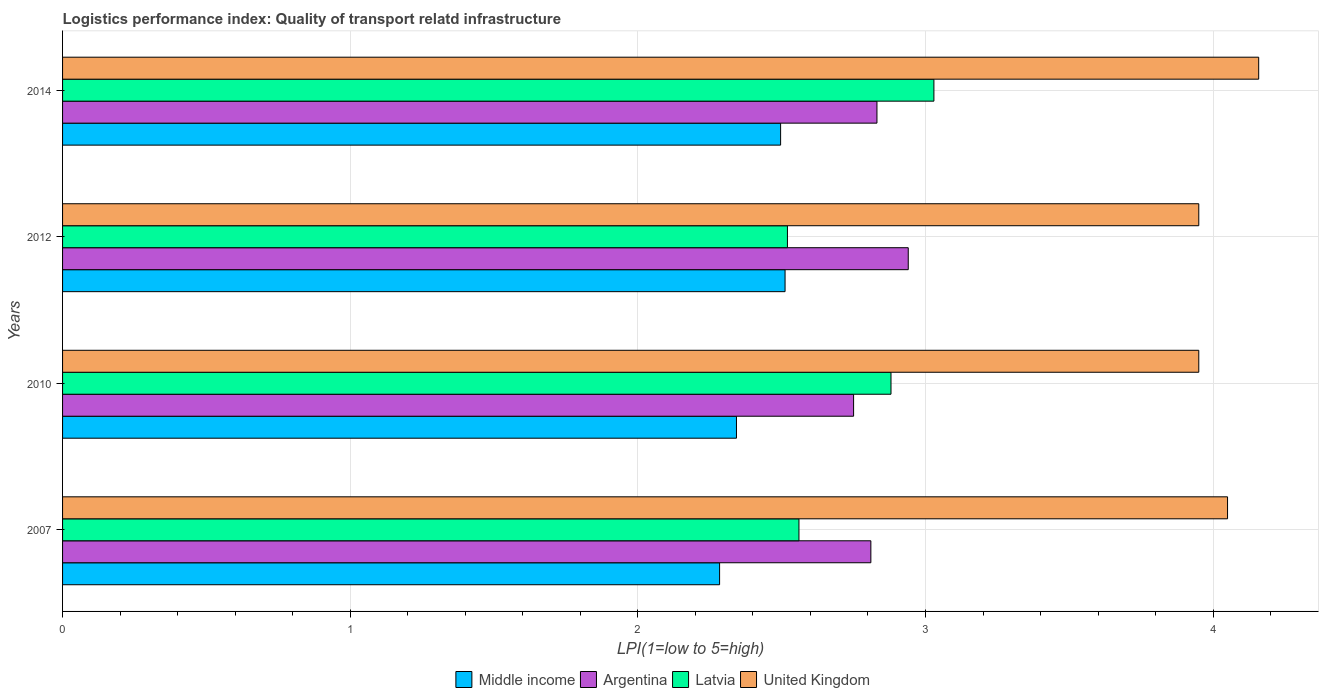How many different coloured bars are there?
Ensure brevity in your answer.  4. How many groups of bars are there?
Provide a short and direct response. 4. Are the number of bars on each tick of the Y-axis equal?
Your answer should be compact. Yes. How many bars are there on the 2nd tick from the top?
Give a very brief answer. 4. How many bars are there on the 3rd tick from the bottom?
Offer a terse response. 4. What is the label of the 1st group of bars from the top?
Your answer should be compact. 2014. In how many cases, is the number of bars for a given year not equal to the number of legend labels?
Offer a terse response. 0. What is the logistics performance index in Latvia in 2012?
Your answer should be very brief. 2.52. Across all years, what is the maximum logistics performance index in United Kingdom?
Give a very brief answer. 4.16. Across all years, what is the minimum logistics performance index in Argentina?
Offer a terse response. 2.75. In which year was the logistics performance index in Middle income minimum?
Ensure brevity in your answer.  2007. What is the total logistics performance index in United Kingdom in the graph?
Offer a terse response. 16.11. What is the difference between the logistics performance index in Argentina in 2010 and that in 2014?
Your response must be concise. -0.08. What is the difference between the logistics performance index in United Kingdom in 2007 and the logistics performance index in Latvia in 2012?
Offer a very short reply. 1.53. What is the average logistics performance index in Middle income per year?
Keep it short and to the point. 2.41. In the year 2014, what is the difference between the logistics performance index in Middle income and logistics performance index in United Kingdom?
Keep it short and to the point. -1.66. In how many years, is the logistics performance index in Middle income greater than 3.6 ?
Offer a very short reply. 0. What is the ratio of the logistics performance index in United Kingdom in 2007 to that in 2010?
Your response must be concise. 1.03. Is the logistics performance index in Latvia in 2007 less than that in 2014?
Your response must be concise. Yes. What is the difference between the highest and the second highest logistics performance index in Latvia?
Give a very brief answer. 0.15. What is the difference between the highest and the lowest logistics performance index in Latvia?
Your answer should be compact. 0.51. In how many years, is the logistics performance index in Latvia greater than the average logistics performance index in Latvia taken over all years?
Your answer should be compact. 2. Is the sum of the logistics performance index in Argentina in 2012 and 2014 greater than the maximum logistics performance index in United Kingdom across all years?
Ensure brevity in your answer.  Yes. Is it the case that in every year, the sum of the logistics performance index in Argentina and logistics performance index in Middle income is greater than the sum of logistics performance index in Latvia and logistics performance index in United Kingdom?
Give a very brief answer. No. What does the 2nd bar from the top in 2014 represents?
Offer a very short reply. Latvia. What does the 2nd bar from the bottom in 2010 represents?
Make the answer very short. Argentina. How many years are there in the graph?
Offer a very short reply. 4. Does the graph contain any zero values?
Your response must be concise. No. Does the graph contain grids?
Ensure brevity in your answer.  Yes. Where does the legend appear in the graph?
Give a very brief answer. Bottom center. How are the legend labels stacked?
Ensure brevity in your answer.  Horizontal. What is the title of the graph?
Provide a short and direct response. Logistics performance index: Quality of transport relatd infrastructure. Does "Norway" appear as one of the legend labels in the graph?
Give a very brief answer. No. What is the label or title of the X-axis?
Ensure brevity in your answer.  LPI(1=low to 5=high). What is the label or title of the Y-axis?
Your response must be concise. Years. What is the LPI(1=low to 5=high) in Middle income in 2007?
Offer a terse response. 2.28. What is the LPI(1=low to 5=high) in Argentina in 2007?
Provide a short and direct response. 2.81. What is the LPI(1=low to 5=high) in Latvia in 2007?
Provide a short and direct response. 2.56. What is the LPI(1=low to 5=high) in United Kingdom in 2007?
Keep it short and to the point. 4.05. What is the LPI(1=low to 5=high) of Middle income in 2010?
Give a very brief answer. 2.34. What is the LPI(1=low to 5=high) in Argentina in 2010?
Keep it short and to the point. 2.75. What is the LPI(1=low to 5=high) in Latvia in 2010?
Keep it short and to the point. 2.88. What is the LPI(1=low to 5=high) in United Kingdom in 2010?
Offer a terse response. 3.95. What is the LPI(1=low to 5=high) in Middle income in 2012?
Provide a succinct answer. 2.51. What is the LPI(1=low to 5=high) in Argentina in 2012?
Keep it short and to the point. 2.94. What is the LPI(1=low to 5=high) in Latvia in 2012?
Offer a very short reply. 2.52. What is the LPI(1=low to 5=high) of United Kingdom in 2012?
Provide a succinct answer. 3.95. What is the LPI(1=low to 5=high) in Middle income in 2014?
Make the answer very short. 2.5. What is the LPI(1=low to 5=high) of Argentina in 2014?
Give a very brief answer. 2.83. What is the LPI(1=low to 5=high) of Latvia in 2014?
Offer a terse response. 3.03. What is the LPI(1=low to 5=high) of United Kingdom in 2014?
Ensure brevity in your answer.  4.16. Across all years, what is the maximum LPI(1=low to 5=high) in Middle income?
Provide a short and direct response. 2.51. Across all years, what is the maximum LPI(1=low to 5=high) of Argentina?
Give a very brief answer. 2.94. Across all years, what is the maximum LPI(1=low to 5=high) of Latvia?
Keep it short and to the point. 3.03. Across all years, what is the maximum LPI(1=low to 5=high) in United Kingdom?
Your answer should be compact. 4.16. Across all years, what is the minimum LPI(1=low to 5=high) of Middle income?
Make the answer very short. 2.28. Across all years, what is the minimum LPI(1=low to 5=high) of Argentina?
Offer a very short reply. 2.75. Across all years, what is the minimum LPI(1=low to 5=high) of Latvia?
Your response must be concise. 2.52. Across all years, what is the minimum LPI(1=low to 5=high) in United Kingdom?
Keep it short and to the point. 3.95. What is the total LPI(1=low to 5=high) of Middle income in the graph?
Make the answer very short. 9.63. What is the total LPI(1=low to 5=high) of Argentina in the graph?
Your answer should be compact. 11.33. What is the total LPI(1=low to 5=high) in Latvia in the graph?
Your answer should be compact. 10.99. What is the total LPI(1=low to 5=high) of United Kingdom in the graph?
Offer a terse response. 16.11. What is the difference between the LPI(1=low to 5=high) in Middle income in 2007 and that in 2010?
Provide a succinct answer. -0.06. What is the difference between the LPI(1=low to 5=high) in Argentina in 2007 and that in 2010?
Your answer should be compact. 0.06. What is the difference between the LPI(1=low to 5=high) in Latvia in 2007 and that in 2010?
Make the answer very short. -0.32. What is the difference between the LPI(1=low to 5=high) in United Kingdom in 2007 and that in 2010?
Your answer should be very brief. 0.1. What is the difference between the LPI(1=low to 5=high) in Middle income in 2007 and that in 2012?
Your answer should be compact. -0.23. What is the difference between the LPI(1=low to 5=high) of Argentina in 2007 and that in 2012?
Provide a short and direct response. -0.13. What is the difference between the LPI(1=low to 5=high) in Latvia in 2007 and that in 2012?
Provide a succinct answer. 0.04. What is the difference between the LPI(1=low to 5=high) in Middle income in 2007 and that in 2014?
Make the answer very short. -0.21. What is the difference between the LPI(1=low to 5=high) in Argentina in 2007 and that in 2014?
Your response must be concise. -0.02. What is the difference between the LPI(1=low to 5=high) in Latvia in 2007 and that in 2014?
Give a very brief answer. -0.47. What is the difference between the LPI(1=low to 5=high) of United Kingdom in 2007 and that in 2014?
Your answer should be very brief. -0.11. What is the difference between the LPI(1=low to 5=high) of Middle income in 2010 and that in 2012?
Make the answer very short. -0.17. What is the difference between the LPI(1=low to 5=high) of Argentina in 2010 and that in 2012?
Ensure brevity in your answer.  -0.19. What is the difference between the LPI(1=low to 5=high) in Latvia in 2010 and that in 2012?
Make the answer very short. 0.36. What is the difference between the LPI(1=low to 5=high) of Middle income in 2010 and that in 2014?
Your answer should be compact. -0.15. What is the difference between the LPI(1=low to 5=high) of Argentina in 2010 and that in 2014?
Offer a very short reply. -0.08. What is the difference between the LPI(1=low to 5=high) in Latvia in 2010 and that in 2014?
Offer a terse response. -0.15. What is the difference between the LPI(1=low to 5=high) in United Kingdom in 2010 and that in 2014?
Your answer should be very brief. -0.21. What is the difference between the LPI(1=low to 5=high) in Middle income in 2012 and that in 2014?
Your response must be concise. 0.02. What is the difference between the LPI(1=low to 5=high) in Argentina in 2012 and that in 2014?
Provide a short and direct response. 0.11. What is the difference between the LPI(1=low to 5=high) in Latvia in 2012 and that in 2014?
Offer a very short reply. -0.51. What is the difference between the LPI(1=low to 5=high) of United Kingdom in 2012 and that in 2014?
Your response must be concise. -0.21. What is the difference between the LPI(1=low to 5=high) in Middle income in 2007 and the LPI(1=low to 5=high) in Argentina in 2010?
Offer a very short reply. -0.47. What is the difference between the LPI(1=low to 5=high) of Middle income in 2007 and the LPI(1=low to 5=high) of Latvia in 2010?
Provide a succinct answer. -0.6. What is the difference between the LPI(1=low to 5=high) of Middle income in 2007 and the LPI(1=low to 5=high) of United Kingdom in 2010?
Your response must be concise. -1.67. What is the difference between the LPI(1=low to 5=high) of Argentina in 2007 and the LPI(1=low to 5=high) of Latvia in 2010?
Give a very brief answer. -0.07. What is the difference between the LPI(1=low to 5=high) of Argentina in 2007 and the LPI(1=low to 5=high) of United Kingdom in 2010?
Offer a terse response. -1.14. What is the difference between the LPI(1=low to 5=high) in Latvia in 2007 and the LPI(1=low to 5=high) in United Kingdom in 2010?
Make the answer very short. -1.39. What is the difference between the LPI(1=low to 5=high) in Middle income in 2007 and the LPI(1=low to 5=high) in Argentina in 2012?
Keep it short and to the point. -0.66. What is the difference between the LPI(1=low to 5=high) in Middle income in 2007 and the LPI(1=low to 5=high) in Latvia in 2012?
Ensure brevity in your answer.  -0.24. What is the difference between the LPI(1=low to 5=high) of Middle income in 2007 and the LPI(1=low to 5=high) of United Kingdom in 2012?
Offer a very short reply. -1.67. What is the difference between the LPI(1=low to 5=high) in Argentina in 2007 and the LPI(1=low to 5=high) in Latvia in 2012?
Your response must be concise. 0.29. What is the difference between the LPI(1=low to 5=high) in Argentina in 2007 and the LPI(1=low to 5=high) in United Kingdom in 2012?
Make the answer very short. -1.14. What is the difference between the LPI(1=low to 5=high) of Latvia in 2007 and the LPI(1=low to 5=high) of United Kingdom in 2012?
Your response must be concise. -1.39. What is the difference between the LPI(1=low to 5=high) of Middle income in 2007 and the LPI(1=low to 5=high) of Argentina in 2014?
Offer a very short reply. -0.55. What is the difference between the LPI(1=low to 5=high) in Middle income in 2007 and the LPI(1=low to 5=high) in Latvia in 2014?
Offer a terse response. -0.74. What is the difference between the LPI(1=low to 5=high) in Middle income in 2007 and the LPI(1=low to 5=high) in United Kingdom in 2014?
Make the answer very short. -1.87. What is the difference between the LPI(1=low to 5=high) of Argentina in 2007 and the LPI(1=low to 5=high) of Latvia in 2014?
Provide a short and direct response. -0.22. What is the difference between the LPI(1=low to 5=high) of Argentina in 2007 and the LPI(1=low to 5=high) of United Kingdom in 2014?
Offer a terse response. -1.35. What is the difference between the LPI(1=low to 5=high) in Latvia in 2007 and the LPI(1=low to 5=high) in United Kingdom in 2014?
Give a very brief answer. -1.6. What is the difference between the LPI(1=low to 5=high) of Middle income in 2010 and the LPI(1=low to 5=high) of Argentina in 2012?
Your answer should be very brief. -0.6. What is the difference between the LPI(1=low to 5=high) in Middle income in 2010 and the LPI(1=low to 5=high) in Latvia in 2012?
Your response must be concise. -0.18. What is the difference between the LPI(1=low to 5=high) in Middle income in 2010 and the LPI(1=low to 5=high) in United Kingdom in 2012?
Your response must be concise. -1.61. What is the difference between the LPI(1=low to 5=high) in Argentina in 2010 and the LPI(1=low to 5=high) in Latvia in 2012?
Ensure brevity in your answer.  0.23. What is the difference between the LPI(1=low to 5=high) in Latvia in 2010 and the LPI(1=low to 5=high) in United Kingdom in 2012?
Provide a succinct answer. -1.07. What is the difference between the LPI(1=low to 5=high) of Middle income in 2010 and the LPI(1=low to 5=high) of Argentina in 2014?
Offer a very short reply. -0.49. What is the difference between the LPI(1=low to 5=high) of Middle income in 2010 and the LPI(1=low to 5=high) of Latvia in 2014?
Your response must be concise. -0.69. What is the difference between the LPI(1=low to 5=high) in Middle income in 2010 and the LPI(1=low to 5=high) in United Kingdom in 2014?
Give a very brief answer. -1.82. What is the difference between the LPI(1=low to 5=high) of Argentina in 2010 and the LPI(1=low to 5=high) of Latvia in 2014?
Provide a succinct answer. -0.28. What is the difference between the LPI(1=low to 5=high) in Argentina in 2010 and the LPI(1=low to 5=high) in United Kingdom in 2014?
Your response must be concise. -1.41. What is the difference between the LPI(1=low to 5=high) of Latvia in 2010 and the LPI(1=low to 5=high) of United Kingdom in 2014?
Your answer should be very brief. -1.28. What is the difference between the LPI(1=low to 5=high) of Middle income in 2012 and the LPI(1=low to 5=high) of Argentina in 2014?
Offer a terse response. -0.32. What is the difference between the LPI(1=low to 5=high) in Middle income in 2012 and the LPI(1=low to 5=high) in Latvia in 2014?
Provide a short and direct response. -0.52. What is the difference between the LPI(1=low to 5=high) of Middle income in 2012 and the LPI(1=low to 5=high) of United Kingdom in 2014?
Make the answer very short. -1.65. What is the difference between the LPI(1=low to 5=high) of Argentina in 2012 and the LPI(1=low to 5=high) of Latvia in 2014?
Provide a short and direct response. -0.09. What is the difference between the LPI(1=low to 5=high) in Argentina in 2012 and the LPI(1=low to 5=high) in United Kingdom in 2014?
Keep it short and to the point. -1.22. What is the difference between the LPI(1=low to 5=high) of Latvia in 2012 and the LPI(1=low to 5=high) of United Kingdom in 2014?
Offer a very short reply. -1.64. What is the average LPI(1=low to 5=high) in Middle income per year?
Give a very brief answer. 2.41. What is the average LPI(1=low to 5=high) in Argentina per year?
Make the answer very short. 2.83. What is the average LPI(1=low to 5=high) in Latvia per year?
Your response must be concise. 2.75. What is the average LPI(1=low to 5=high) of United Kingdom per year?
Keep it short and to the point. 4.03. In the year 2007, what is the difference between the LPI(1=low to 5=high) in Middle income and LPI(1=low to 5=high) in Argentina?
Your answer should be compact. -0.53. In the year 2007, what is the difference between the LPI(1=low to 5=high) in Middle income and LPI(1=low to 5=high) in Latvia?
Give a very brief answer. -0.28. In the year 2007, what is the difference between the LPI(1=low to 5=high) in Middle income and LPI(1=low to 5=high) in United Kingdom?
Provide a short and direct response. -1.77. In the year 2007, what is the difference between the LPI(1=low to 5=high) of Argentina and LPI(1=low to 5=high) of United Kingdom?
Provide a short and direct response. -1.24. In the year 2007, what is the difference between the LPI(1=low to 5=high) of Latvia and LPI(1=low to 5=high) of United Kingdom?
Make the answer very short. -1.49. In the year 2010, what is the difference between the LPI(1=low to 5=high) in Middle income and LPI(1=low to 5=high) in Argentina?
Offer a very short reply. -0.41. In the year 2010, what is the difference between the LPI(1=low to 5=high) in Middle income and LPI(1=low to 5=high) in Latvia?
Your answer should be compact. -0.54. In the year 2010, what is the difference between the LPI(1=low to 5=high) in Middle income and LPI(1=low to 5=high) in United Kingdom?
Make the answer very short. -1.61. In the year 2010, what is the difference between the LPI(1=low to 5=high) in Argentina and LPI(1=low to 5=high) in Latvia?
Provide a succinct answer. -0.13. In the year 2010, what is the difference between the LPI(1=low to 5=high) of Latvia and LPI(1=low to 5=high) of United Kingdom?
Ensure brevity in your answer.  -1.07. In the year 2012, what is the difference between the LPI(1=low to 5=high) of Middle income and LPI(1=low to 5=high) of Argentina?
Offer a very short reply. -0.43. In the year 2012, what is the difference between the LPI(1=low to 5=high) in Middle income and LPI(1=low to 5=high) in Latvia?
Give a very brief answer. -0.01. In the year 2012, what is the difference between the LPI(1=low to 5=high) of Middle income and LPI(1=low to 5=high) of United Kingdom?
Offer a very short reply. -1.44. In the year 2012, what is the difference between the LPI(1=low to 5=high) of Argentina and LPI(1=low to 5=high) of Latvia?
Offer a very short reply. 0.42. In the year 2012, what is the difference between the LPI(1=low to 5=high) of Argentina and LPI(1=low to 5=high) of United Kingdom?
Keep it short and to the point. -1.01. In the year 2012, what is the difference between the LPI(1=low to 5=high) in Latvia and LPI(1=low to 5=high) in United Kingdom?
Make the answer very short. -1.43. In the year 2014, what is the difference between the LPI(1=low to 5=high) of Middle income and LPI(1=low to 5=high) of Argentina?
Offer a very short reply. -0.33. In the year 2014, what is the difference between the LPI(1=low to 5=high) of Middle income and LPI(1=low to 5=high) of Latvia?
Ensure brevity in your answer.  -0.53. In the year 2014, what is the difference between the LPI(1=low to 5=high) in Middle income and LPI(1=low to 5=high) in United Kingdom?
Keep it short and to the point. -1.66. In the year 2014, what is the difference between the LPI(1=low to 5=high) in Argentina and LPI(1=low to 5=high) in Latvia?
Offer a very short reply. -0.2. In the year 2014, what is the difference between the LPI(1=low to 5=high) of Argentina and LPI(1=low to 5=high) of United Kingdom?
Make the answer very short. -1.33. In the year 2014, what is the difference between the LPI(1=low to 5=high) of Latvia and LPI(1=low to 5=high) of United Kingdom?
Your answer should be very brief. -1.13. What is the ratio of the LPI(1=low to 5=high) in Middle income in 2007 to that in 2010?
Your answer should be very brief. 0.97. What is the ratio of the LPI(1=low to 5=high) in Argentina in 2007 to that in 2010?
Offer a very short reply. 1.02. What is the ratio of the LPI(1=low to 5=high) of United Kingdom in 2007 to that in 2010?
Make the answer very short. 1.03. What is the ratio of the LPI(1=low to 5=high) of Middle income in 2007 to that in 2012?
Provide a succinct answer. 0.91. What is the ratio of the LPI(1=low to 5=high) in Argentina in 2007 to that in 2012?
Offer a terse response. 0.96. What is the ratio of the LPI(1=low to 5=high) of Latvia in 2007 to that in 2012?
Ensure brevity in your answer.  1.02. What is the ratio of the LPI(1=low to 5=high) of United Kingdom in 2007 to that in 2012?
Offer a very short reply. 1.03. What is the ratio of the LPI(1=low to 5=high) of Middle income in 2007 to that in 2014?
Your answer should be very brief. 0.92. What is the ratio of the LPI(1=low to 5=high) in Argentina in 2007 to that in 2014?
Your response must be concise. 0.99. What is the ratio of the LPI(1=low to 5=high) of Latvia in 2007 to that in 2014?
Ensure brevity in your answer.  0.85. What is the ratio of the LPI(1=low to 5=high) in Middle income in 2010 to that in 2012?
Ensure brevity in your answer.  0.93. What is the ratio of the LPI(1=low to 5=high) of Argentina in 2010 to that in 2012?
Offer a very short reply. 0.94. What is the ratio of the LPI(1=low to 5=high) of Latvia in 2010 to that in 2012?
Provide a succinct answer. 1.14. What is the ratio of the LPI(1=low to 5=high) of United Kingdom in 2010 to that in 2012?
Your answer should be very brief. 1. What is the ratio of the LPI(1=low to 5=high) of Middle income in 2010 to that in 2014?
Keep it short and to the point. 0.94. What is the ratio of the LPI(1=low to 5=high) of Argentina in 2010 to that in 2014?
Give a very brief answer. 0.97. What is the ratio of the LPI(1=low to 5=high) in Latvia in 2010 to that in 2014?
Keep it short and to the point. 0.95. What is the ratio of the LPI(1=low to 5=high) in United Kingdom in 2010 to that in 2014?
Make the answer very short. 0.95. What is the ratio of the LPI(1=low to 5=high) of Middle income in 2012 to that in 2014?
Keep it short and to the point. 1.01. What is the ratio of the LPI(1=low to 5=high) in Argentina in 2012 to that in 2014?
Make the answer very short. 1.04. What is the ratio of the LPI(1=low to 5=high) in Latvia in 2012 to that in 2014?
Provide a short and direct response. 0.83. What is the ratio of the LPI(1=low to 5=high) in United Kingdom in 2012 to that in 2014?
Give a very brief answer. 0.95. What is the difference between the highest and the second highest LPI(1=low to 5=high) of Middle income?
Provide a succinct answer. 0.02. What is the difference between the highest and the second highest LPI(1=low to 5=high) in Argentina?
Your response must be concise. 0.11. What is the difference between the highest and the second highest LPI(1=low to 5=high) in Latvia?
Offer a terse response. 0.15. What is the difference between the highest and the second highest LPI(1=low to 5=high) in United Kingdom?
Ensure brevity in your answer.  0.11. What is the difference between the highest and the lowest LPI(1=low to 5=high) of Middle income?
Give a very brief answer. 0.23. What is the difference between the highest and the lowest LPI(1=low to 5=high) of Argentina?
Ensure brevity in your answer.  0.19. What is the difference between the highest and the lowest LPI(1=low to 5=high) in Latvia?
Your answer should be compact. 0.51. What is the difference between the highest and the lowest LPI(1=low to 5=high) of United Kingdom?
Give a very brief answer. 0.21. 